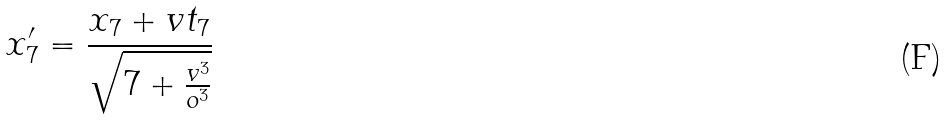<formula> <loc_0><loc_0><loc_500><loc_500>x _ { 7 } ^ { \prime } = \frac { x _ { 7 } + v t _ { 7 } } { \sqrt { 7 + \frac { v ^ { 3 } } { o ^ { 3 } } } }</formula> 